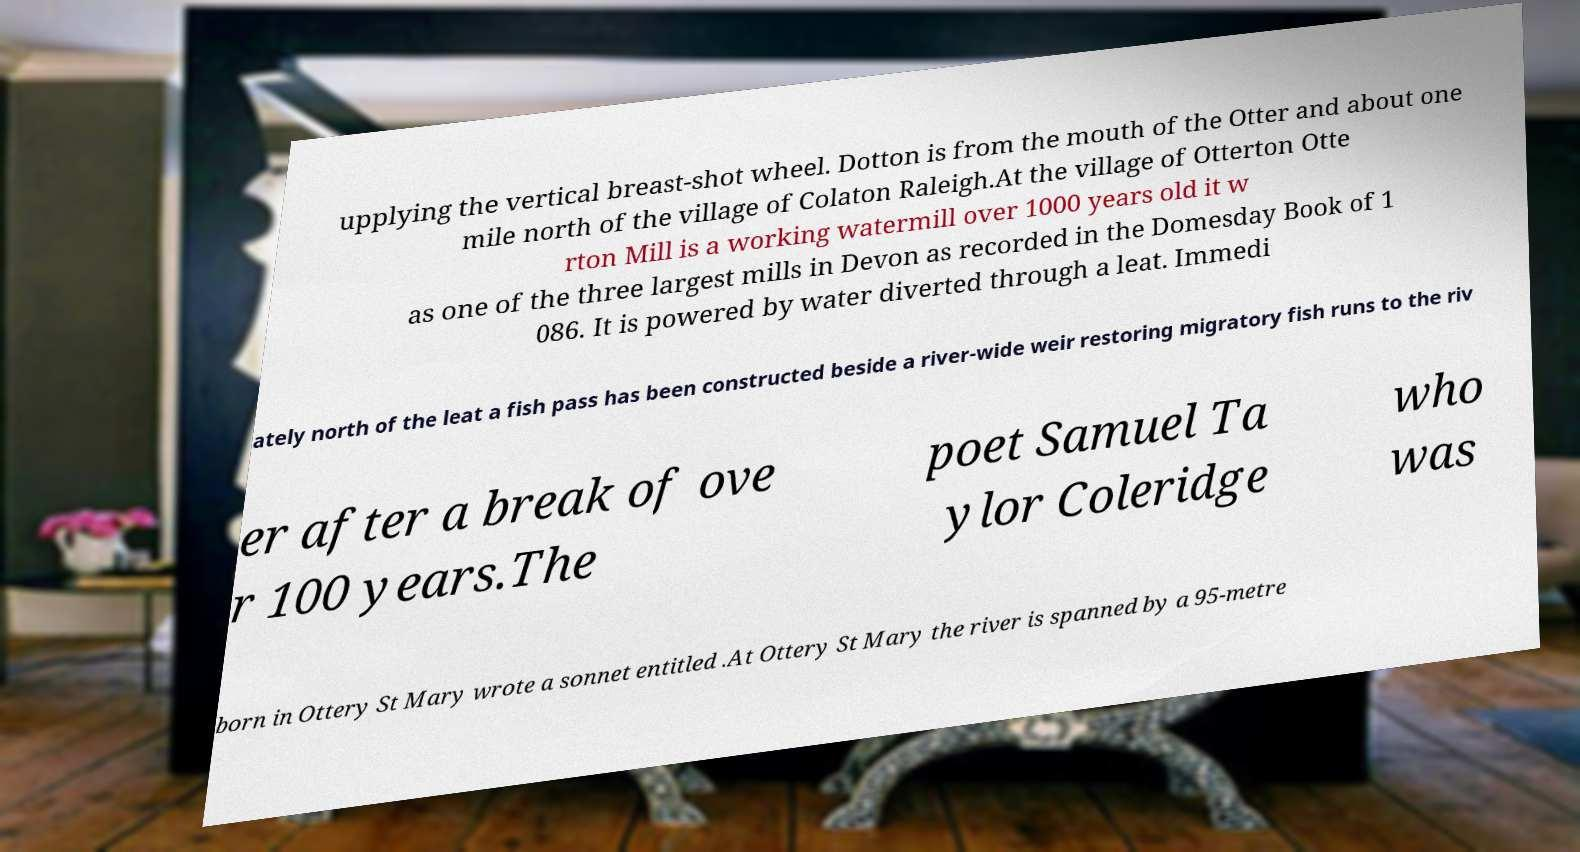Can you read and provide the text displayed in the image?This photo seems to have some interesting text. Can you extract and type it out for me? upplying the vertical breast-shot wheel. Dotton is from the mouth of the Otter and about one mile north of the village of Colaton Raleigh.At the village of Otterton Otte rton Mill is a working watermill over 1000 years old it w as one of the three largest mills in Devon as recorded in the Domesday Book of 1 086. It is powered by water diverted through a leat. Immedi ately north of the leat a fish pass has been constructed beside a river-wide weir restoring migratory fish runs to the riv er after a break of ove r 100 years.The poet Samuel Ta ylor Coleridge who was born in Ottery St Mary wrote a sonnet entitled .At Ottery St Mary the river is spanned by a 95-metre 